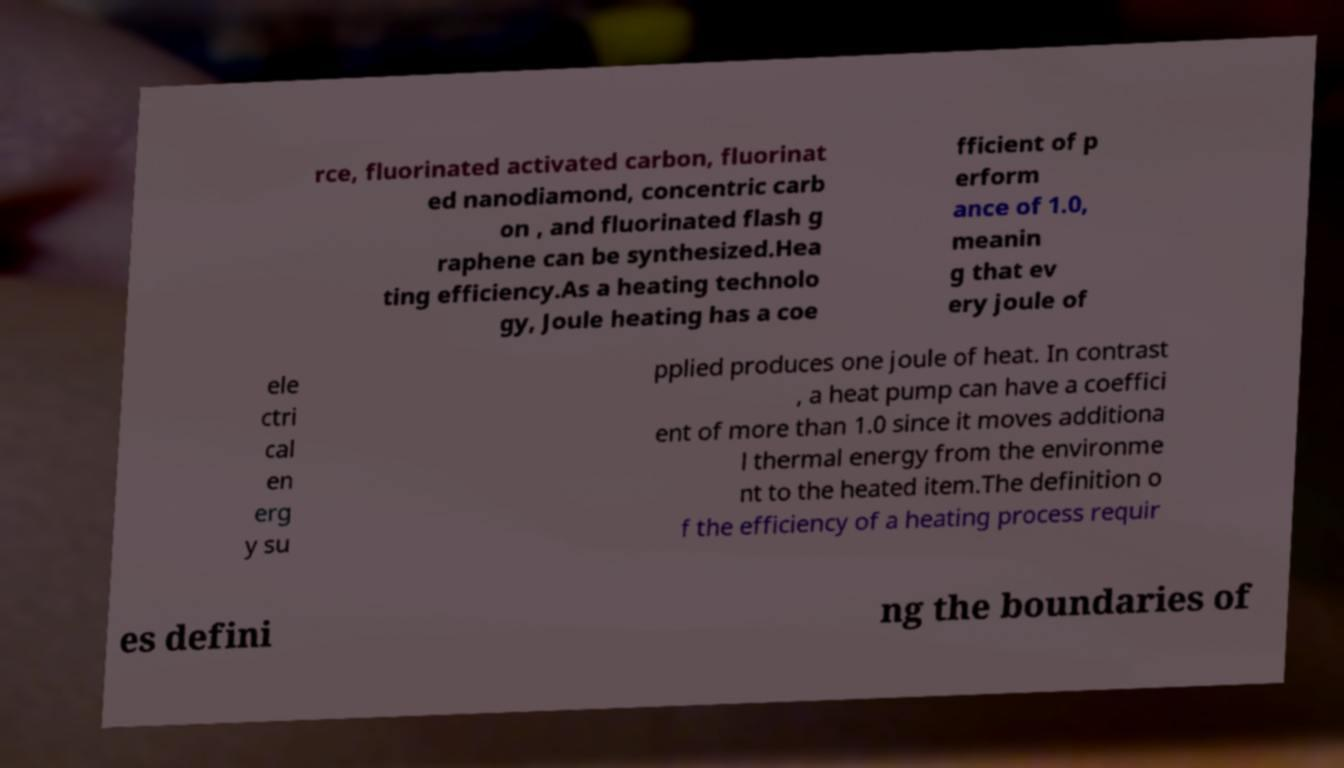Could you extract and type out the text from this image? rce, fluorinated activated carbon, fluorinat ed nanodiamond, concentric carb on , and fluorinated flash g raphene can be synthesized.Hea ting efficiency.As a heating technolo gy, Joule heating has a coe fficient of p erform ance of 1.0, meanin g that ev ery joule of ele ctri cal en erg y su pplied produces one joule of heat. In contrast , a heat pump can have a coeffici ent of more than 1.0 since it moves additiona l thermal energy from the environme nt to the heated item.The definition o f the efficiency of a heating process requir es defini ng the boundaries of 